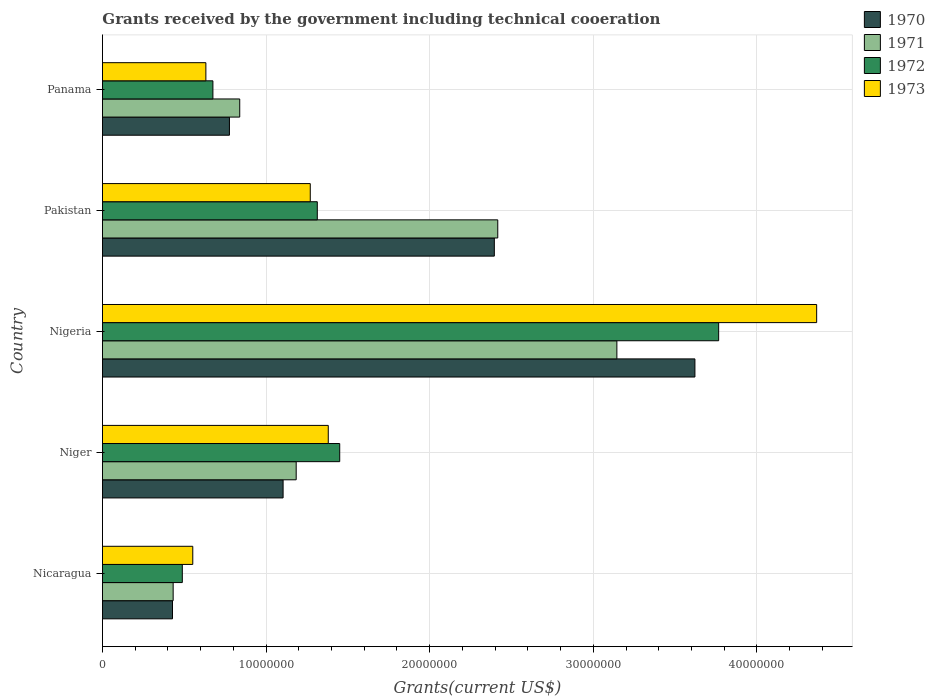Are the number of bars on each tick of the Y-axis equal?
Your answer should be very brief. Yes. How many bars are there on the 5th tick from the top?
Make the answer very short. 4. What is the total grants received by the government in 1970 in Nicaragua?
Provide a succinct answer. 4.28e+06. Across all countries, what is the maximum total grants received by the government in 1970?
Make the answer very short. 3.62e+07. Across all countries, what is the minimum total grants received by the government in 1970?
Make the answer very short. 4.28e+06. In which country was the total grants received by the government in 1970 maximum?
Ensure brevity in your answer.  Nigeria. In which country was the total grants received by the government in 1972 minimum?
Provide a succinct answer. Nicaragua. What is the total total grants received by the government in 1973 in the graph?
Your answer should be very brief. 8.20e+07. What is the difference between the total grants received by the government in 1971 in Nigeria and that in Pakistan?
Offer a terse response. 7.28e+06. What is the difference between the total grants received by the government in 1972 in Niger and the total grants received by the government in 1970 in Panama?
Provide a short and direct response. 6.74e+06. What is the average total grants received by the government in 1972 per country?
Your answer should be compact. 1.54e+07. What is the difference between the total grants received by the government in 1973 and total grants received by the government in 1971 in Nigeria?
Provide a short and direct response. 1.22e+07. In how many countries, is the total grants received by the government in 1971 greater than 30000000 US$?
Ensure brevity in your answer.  1. What is the ratio of the total grants received by the government in 1970 in Nigeria to that in Pakistan?
Offer a very short reply. 1.51. What is the difference between the highest and the second highest total grants received by the government in 1973?
Give a very brief answer. 2.98e+07. What is the difference between the highest and the lowest total grants received by the government in 1971?
Offer a terse response. 2.71e+07. Is the sum of the total grants received by the government in 1970 in Nigeria and Pakistan greater than the maximum total grants received by the government in 1973 across all countries?
Offer a terse response. Yes. Is it the case that in every country, the sum of the total grants received by the government in 1971 and total grants received by the government in 1973 is greater than the sum of total grants received by the government in 1972 and total grants received by the government in 1970?
Make the answer very short. No. What does the 3rd bar from the top in Niger represents?
Offer a terse response. 1971. What does the 1st bar from the bottom in Niger represents?
Make the answer very short. 1970. Is it the case that in every country, the sum of the total grants received by the government in 1971 and total grants received by the government in 1973 is greater than the total grants received by the government in 1970?
Keep it short and to the point. Yes. How many countries are there in the graph?
Your response must be concise. 5. What is the difference between two consecutive major ticks on the X-axis?
Offer a terse response. 1.00e+07. Are the values on the major ticks of X-axis written in scientific E-notation?
Offer a terse response. No. Does the graph contain any zero values?
Offer a very short reply. No. Does the graph contain grids?
Ensure brevity in your answer.  Yes. Where does the legend appear in the graph?
Your response must be concise. Top right. How many legend labels are there?
Your answer should be compact. 4. How are the legend labels stacked?
Ensure brevity in your answer.  Vertical. What is the title of the graph?
Offer a very short reply. Grants received by the government including technical cooeration. Does "1991" appear as one of the legend labels in the graph?
Your answer should be compact. No. What is the label or title of the X-axis?
Keep it short and to the point. Grants(current US$). What is the label or title of the Y-axis?
Offer a terse response. Country. What is the Grants(current US$) of 1970 in Nicaragua?
Your response must be concise. 4.28e+06. What is the Grants(current US$) in 1971 in Nicaragua?
Your answer should be compact. 4.32e+06. What is the Grants(current US$) in 1972 in Nicaragua?
Provide a succinct answer. 4.88e+06. What is the Grants(current US$) in 1973 in Nicaragua?
Offer a terse response. 5.52e+06. What is the Grants(current US$) of 1970 in Niger?
Make the answer very short. 1.10e+07. What is the Grants(current US$) of 1971 in Niger?
Your response must be concise. 1.18e+07. What is the Grants(current US$) in 1972 in Niger?
Provide a short and direct response. 1.45e+07. What is the Grants(current US$) of 1973 in Niger?
Provide a succinct answer. 1.38e+07. What is the Grants(current US$) in 1970 in Nigeria?
Your answer should be very brief. 3.62e+07. What is the Grants(current US$) of 1971 in Nigeria?
Provide a short and direct response. 3.14e+07. What is the Grants(current US$) of 1972 in Nigeria?
Your answer should be very brief. 3.77e+07. What is the Grants(current US$) in 1973 in Nigeria?
Offer a very short reply. 4.36e+07. What is the Grants(current US$) in 1970 in Pakistan?
Offer a terse response. 2.40e+07. What is the Grants(current US$) in 1971 in Pakistan?
Keep it short and to the point. 2.42e+07. What is the Grants(current US$) of 1972 in Pakistan?
Make the answer very short. 1.31e+07. What is the Grants(current US$) of 1973 in Pakistan?
Ensure brevity in your answer.  1.27e+07. What is the Grants(current US$) in 1970 in Panama?
Provide a succinct answer. 7.76e+06. What is the Grants(current US$) in 1971 in Panama?
Give a very brief answer. 8.39e+06. What is the Grants(current US$) of 1972 in Panama?
Keep it short and to the point. 6.75e+06. What is the Grants(current US$) in 1973 in Panama?
Offer a terse response. 6.32e+06. Across all countries, what is the maximum Grants(current US$) of 1970?
Provide a short and direct response. 3.62e+07. Across all countries, what is the maximum Grants(current US$) in 1971?
Keep it short and to the point. 3.14e+07. Across all countries, what is the maximum Grants(current US$) of 1972?
Your answer should be compact. 3.77e+07. Across all countries, what is the maximum Grants(current US$) in 1973?
Keep it short and to the point. 4.36e+07. Across all countries, what is the minimum Grants(current US$) in 1970?
Your answer should be compact. 4.28e+06. Across all countries, what is the minimum Grants(current US$) in 1971?
Give a very brief answer. 4.32e+06. Across all countries, what is the minimum Grants(current US$) of 1972?
Give a very brief answer. 4.88e+06. Across all countries, what is the minimum Grants(current US$) in 1973?
Your answer should be very brief. 5.52e+06. What is the total Grants(current US$) in 1970 in the graph?
Your answer should be compact. 8.32e+07. What is the total Grants(current US$) of 1971 in the graph?
Your response must be concise. 8.02e+07. What is the total Grants(current US$) in 1972 in the graph?
Ensure brevity in your answer.  7.69e+07. What is the total Grants(current US$) of 1973 in the graph?
Your answer should be very brief. 8.20e+07. What is the difference between the Grants(current US$) of 1970 in Nicaragua and that in Niger?
Offer a very short reply. -6.76e+06. What is the difference between the Grants(current US$) in 1971 in Nicaragua and that in Niger?
Provide a short and direct response. -7.52e+06. What is the difference between the Grants(current US$) in 1972 in Nicaragua and that in Niger?
Provide a succinct answer. -9.62e+06. What is the difference between the Grants(current US$) in 1973 in Nicaragua and that in Niger?
Keep it short and to the point. -8.28e+06. What is the difference between the Grants(current US$) in 1970 in Nicaragua and that in Nigeria?
Your response must be concise. -3.19e+07. What is the difference between the Grants(current US$) of 1971 in Nicaragua and that in Nigeria?
Your answer should be very brief. -2.71e+07. What is the difference between the Grants(current US$) in 1972 in Nicaragua and that in Nigeria?
Offer a terse response. -3.28e+07. What is the difference between the Grants(current US$) of 1973 in Nicaragua and that in Nigeria?
Provide a succinct answer. -3.81e+07. What is the difference between the Grants(current US$) in 1970 in Nicaragua and that in Pakistan?
Your answer should be very brief. -1.97e+07. What is the difference between the Grants(current US$) in 1971 in Nicaragua and that in Pakistan?
Your answer should be very brief. -1.98e+07. What is the difference between the Grants(current US$) of 1972 in Nicaragua and that in Pakistan?
Offer a very short reply. -8.25e+06. What is the difference between the Grants(current US$) in 1973 in Nicaragua and that in Pakistan?
Your answer should be compact. -7.18e+06. What is the difference between the Grants(current US$) in 1970 in Nicaragua and that in Panama?
Ensure brevity in your answer.  -3.48e+06. What is the difference between the Grants(current US$) in 1971 in Nicaragua and that in Panama?
Ensure brevity in your answer.  -4.07e+06. What is the difference between the Grants(current US$) of 1972 in Nicaragua and that in Panama?
Provide a succinct answer. -1.87e+06. What is the difference between the Grants(current US$) of 1973 in Nicaragua and that in Panama?
Your answer should be compact. -8.00e+05. What is the difference between the Grants(current US$) in 1970 in Niger and that in Nigeria?
Offer a very short reply. -2.52e+07. What is the difference between the Grants(current US$) of 1971 in Niger and that in Nigeria?
Offer a very short reply. -1.96e+07. What is the difference between the Grants(current US$) of 1972 in Niger and that in Nigeria?
Provide a succinct answer. -2.32e+07. What is the difference between the Grants(current US$) in 1973 in Niger and that in Nigeria?
Give a very brief answer. -2.98e+07. What is the difference between the Grants(current US$) of 1970 in Niger and that in Pakistan?
Your response must be concise. -1.29e+07. What is the difference between the Grants(current US$) in 1971 in Niger and that in Pakistan?
Ensure brevity in your answer.  -1.23e+07. What is the difference between the Grants(current US$) of 1972 in Niger and that in Pakistan?
Your answer should be compact. 1.37e+06. What is the difference between the Grants(current US$) in 1973 in Niger and that in Pakistan?
Your answer should be compact. 1.10e+06. What is the difference between the Grants(current US$) in 1970 in Niger and that in Panama?
Your answer should be very brief. 3.28e+06. What is the difference between the Grants(current US$) of 1971 in Niger and that in Panama?
Your answer should be compact. 3.45e+06. What is the difference between the Grants(current US$) in 1972 in Niger and that in Panama?
Offer a very short reply. 7.75e+06. What is the difference between the Grants(current US$) of 1973 in Niger and that in Panama?
Give a very brief answer. 7.48e+06. What is the difference between the Grants(current US$) in 1970 in Nigeria and that in Pakistan?
Provide a short and direct response. 1.23e+07. What is the difference between the Grants(current US$) in 1971 in Nigeria and that in Pakistan?
Provide a short and direct response. 7.28e+06. What is the difference between the Grants(current US$) in 1972 in Nigeria and that in Pakistan?
Ensure brevity in your answer.  2.45e+07. What is the difference between the Grants(current US$) in 1973 in Nigeria and that in Pakistan?
Your response must be concise. 3.10e+07. What is the difference between the Grants(current US$) of 1970 in Nigeria and that in Panama?
Your response must be concise. 2.84e+07. What is the difference between the Grants(current US$) in 1971 in Nigeria and that in Panama?
Offer a terse response. 2.30e+07. What is the difference between the Grants(current US$) in 1972 in Nigeria and that in Panama?
Keep it short and to the point. 3.09e+07. What is the difference between the Grants(current US$) of 1973 in Nigeria and that in Panama?
Offer a terse response. 3.73e+07. What is the difference between the Grants(current US$) in 1970 in Pakistan and that in Panama?
Your answer should be very brief. 1.62e+07. What is the difference between the Grants(current US$) of 1971 in Pakistan and that in Panama?
Offer a terse response. 1.58e+07. What is the difference between the Grants(current US$) in 1972 in Pakistan and that in Panama?
Give a very brief answer. 6.38e+06. What is the difference between the Grants(current US$) of 1973 in Pakistan and that in Panama?
Offer a terse response. 6.38e+06. What is the difference between the Grants(current US$) in 1970 in Nicaragua and the Grants(current US$) in 1971 in Niger?
Offer a terse response. -7.56e+06. What is the difference between the Grants(current US$) of 1970 in Nicaragua and the Grants(current US$) of 1972 in Niger?
Give a very brief answer. -1.02e+07. What is the difference between the Grants(current US$) of 1970 in Nicaragua and the Grants(current US$) of 1973 in Niger?
Offer a very short reply. -9.52e+06. What is the difference between the Grants(current US$) in 1971 in Nicaragua and the Grants(current US$) in 1972 in Niger?
Give a very brief answer. -1.02e+07. What is the difference between the Grants(current US$) of 1971 in Nicaragua and the Grants(current US$) of 1973 in Niger?
Offer a terse response. -9.48e+06. What is the difference between the Grants(current US$) of 1972 in Nicaragua and the Grants(current US$) of 1973 in Niger?
Offer a very short reply. -8.92e+06. What is the difference between the Grants(current US$) in 1970 in Nicaragua and the Grants(current US$) in 1971 in Nigeria?
Keep it short and to the point. -2.72e+07. What is the difference between the Grants(current US$) in 1970 in Nicaragua and the Grants(current US$) in 1972 in Nigeria?
Provide a succinct answer. -3.34e+07. What is the difference between the Grants(current US$) of 1970 in Nicaragua and the Grants(current US$) of 1973 in Nigeria?
Offer a terse response. -3.94e+07. What is the difference between the Grants(current US$) in 1971 in Nicaragua and the Grants(current US$) in 1972 in Nigeria?
Give a very brief answer. -3.33e+07. What is the difference between the Grants(current US$) in 1971 in Nicaragua and the Grants(current US$) in 1973 in Nigeria?
Provide a short and direct response. -3.93e+07. What is the difference between the Grants(current US$) in 1972 in Nicaragua and the Grants(current US$) in 1973 in Nigeria?
Make the answer very short. -3.88e+07. What is the difference between the Grants(current US$) of 1970 in Nicaragua and the Grants(current US$) of 1971 in Pakistan?
Provide a short and direct response. -1.99e+07. What is the difference between the Grants(current US$) of 1970 in Nicaragua and the Grants(current US$) of 1972 in Pakistan?
Offer a terse response. -8.85e+06. What is the difference between the Grants(current US$) in 1970 in Nicaragua and the Grants(current US$) in 1973 in Pakistan?
Keep it short and to the point. -8.42e+06. What is the difference between the Grants(current US$) of 1971 in Nicaragua and the Grants(current US$) of 1972 in Pakistan?
Your answer should be very brief. -8.81e+06. What is the difference between the Grants(current US$) of 1971 in Nicaragua and the Grants(current US$) of 1973 in Pakistan?
Keep it short and to the point. -8.38e+06. What is the difference between the Grants(current US$) of 1972 in Nicaragua and the Grants(current US$) of 1973 in Pakistan?
Give a very brief answer. -7.82e+06. What is the difference between the Grants(current US$) in 1970 in Nicaragua and the Grants(current US$) in 1971 in Panama?
Offer a terse response. -4.11e+06. What is the difference between the Grants(current US$) of 1970 in Nicaragua and the Grants(current US$) of 1972 in Panama?
Make the answer very short. -2.47e+06. What is the difference between the Grants(current US$) in 1970 in Nicaragua and the Grants(current US$) in 1973 in Panama?
Your answer should be compact. -2.04e+06. What is the difference between the Grants(current US$) of 1971 in Nicaragua and the Grants(current US$) of 1972 in Panama?
Keep it short and to the point. -2.43e+06. What is the difference between the Grants(current US$) of 1972 in Nicaragua and the Grants(current US$) of 1973 in Panama?
Your answer should be very brief. -1.44e+06. What is the difference between the Grants(current US$) of 1970 in Niger and the Grants(current US$) of 1971 in Nigeria?
Offer a terse response. -2.04e+07. What is the difference between the Grants(current US$) in 1970 in Niger and the Grants(current US$) in 1972 in Nigeria?
Provide a succinct answer. -2.66e+07. What is the difference between the Grants(current US$) in 1970 in Niger and the Grants(current US$) in 1973 in Nigeria?
Provide a short and direct response. -3.26e+07. What is the difference between the Grants(current US$) of 1971 in Niger and the Grants(current US$) of 1972 in Nigeria?
Ensure brevity in your answer.  -2.58e+07. What is the difference between the Grants(current US$) in 1971 in Niger and the Grants(current US$) in 1973 in Nigeria?
Ensure brevity in your answer.  -3.18e+07. What is the difference between the Grants(current US$) in 1972 in Niger and the Grants(current US$) in 1973 in Nigeria?
Your answer should be compact. -2.92e+07. What is the difference between the Grants(current US$) of 1970 in Niger and the Grants(current US$) of 1971 in Pakistan?
Make the answer very short. -1.31e+07. What is the difference between the Grants(current US$) of 1970 in Niger and the Grants(current US$) of 1972 in Pakistan?
Your response must be concise. -2.09e+06. What is the difference between the Grants(current US$) in 1970 in Niger and the Grants(current US$) in 1973 in Pakistan?
Ensure brevity in your answer.  -1.66e+06. What is the difference between the Grants(current US$) of 1971 in Niger and the Grants(current US$) of 1972 in Pakistan?
Ensure brevity in your answer.  -1.29e+06. What is the difference between the Grants(current US$) of 1971 in Niger and the Grants(current US$) of 1973 in Pakistan?
Offer a very short reply. -8.60e+05. What is the difference between the Grants(current US$) in 1972 in Niger and the Grants(current US$) in 1973 in Pakistan?
Provide a short and direct response. 1.80e+06. What is the difference between the Grants(current US$) in 1970 in Niger and the Grants(current US$) in 1971 in Panama?
Keep it short and to the point. 2.65e+06. What is the difference between the Grants(current US$) of 1970 in Niger and the Grants(current US$) of 1972 in Panama?
Provide a short and direct response. 4.29e+06. What is the difference between the Grants(current US$) of 1970 in Niger and the Grants(current US$) of 1973 in Panama?
Ensure brevity in your answer.  4.72e+06. What is the difference between the Grants(current US$) of 1971 in Niger and the Grants(current US$) of 1972 in Panama?
Your response must be concise. 5.09e+06. What is the difference between the Grants(current US$) of 1971 in Niger and the Grants(current US$) of 1973 in Panama?
Give a very brief answer. 5.52e+06. What is the difference between the Grants(current US$) in 1972 in Niger and the Grants(current US$) in 1973 in Panama?
Your answer should be compact. 8.18e+06. What is the difference between the Grants(current US$) in 1970 in Nigeria and the Grants(current US$) in 1971 in Pakistan?
Your answer should be compact. 1.20e+07. What is the difference between the Grants(current US$) of 1970 in Nigeria and the Grants(current US$) of 1972 in Pakistan?
Your answer should be very brief. 2.31e+07. What is the difference between the Grants(current US$) in 1970 in Nigeria and the Grants(current US$) in 1973 in Pakistan?
Your answer should be compact. 2.35e+07. What is the difference between the Grants(current US$) of 1971 in Nigeria and the Grants(current US$) of 1972 in Pakistan?
Your answer should be very brief. 1.83e+07. What is the difference between the Grants(current US$) in 1971 in Nigeria and the Grants(current US$) in 1973 in Pakistan?
Ensure brevity in your answer.  1.87e+07. What is the difference between the Grants(current US$) of 1972 in Nigeria and the Grants(current US$) of 1973 in Pakistan?
Make the answer very short. 2.50e+07. What is the difference between the Grants(current US$) in 1970 in Nigeria and the Grants(current US$) in 1971 in Panama?
Give a very brief answer. 2.78e+07. What is the difference between the Grants(current US$) of 1970 in Nigeria and the Grants(current US$) of 1972 in Panama?
Offer a very short reply. 2.95e+07. What is the difference between the Grants(current US$) of 1970 in Nigeria and the Grants(current US$) of 1973 in Panama?
Ensure brevity in your answer.  2.99e+07. What is the difference between the Grants(current US$) in 1971 in Nigeria and the Grants(current US$) in 1972 in Panama?
Offer a terse response. 2.47e+07. What is the difference between the Grants(current US$) of 1971 in Nigeria and the Grants(current US$) of 1973 in Panama?
Provide a succinct answer. 2.51e+07. What is the difference between the Grants(current US$) in 1972 in Nigeria and the Grants(current US$) in 1973 in Panama?
Your answer should be compact. 3.13e+07. What is the difference between the Grants(current US$) in 1970 in Pakistan and the Grants(current US$) in 1971 in Panama?
Provide a succinct answer. 1.56e+07. What is the difference between the Grants(current US$) of 1970 in Pakistan and the Grants(current US$) of 1972 in Panama?
Provide a succinct answer. 1.72e+07. What is the difference between the Grants(current US$) in 1970 in Pakistan and the Grants(current US$) in 1973 in Panama?
Give a very brief answer. 1.76e+07. What is the difference between the Grants(current US$) in 1971 in Pakistan and the Grants(current US$) in 1972 in Panama?
Offer a very short reply. 1.74e+07. What is the difference between the Grants(current US$) of 1971 in Pakistan and the Grants(current US$) of 1973 in Panama?
Give a very brief answer. 1.78e+07. What is the difference between the Grants(current US$) of 1972 in Pakistan and the Grants(current US$) of 1973 in Panama?
Ensure brevity in your answer.  6.81e+06. What is the average Grants(current US$) in 1970 per country?
Make the answer very short. 1.66e+07. What is the average Grants(current US$) in 1971 per country?
Keep it short and to the point. 1.60e+07. What is the average Grants(current US$) in 1972 per country?
Your answer should be very brief. 1.54e+07. What is the average Grants(current US$) in 1973 per country?
Make the answer very short. 1.64e+07. What is the difference between the Grants(current US$) in 1970 and Grants(current US$) in 1971 in Nicaragua?
Give a very brief answer. -4.00e+04. What is the difference between the Grants(current US$) of 1970 and Grants(current US$) of 1972 in Nicaragua?
Provide a succinct answer. -6.00e+05. What is the difference between the Grants(current US$) of 1970 and Grants(current US$) of 1973 in Nicaragua?
Your answer should be compact. -1.24e+06. What is the difference between the Grants(current US$) in 1971 and Grants(current US$) in 1972 in Nicaragua?
Offer a very short reply. -5.60e+05. What is the difference between the Grants(current US$) in 1971 and Grants(current US$) in 1973 in Nicaragua?
Offer a very short reply. -1.20e+06. What is the difference between the Grants(current US$) in 1972 and Grants(current US$) in 1973 in Nicaragua?
Keep it short and to the point. -6.40e+05. What is the difference between the Grants(current US$) in 1970 and Grants(current US$) in 1971 in Niger?
Give a very brief answer. -8.00e+05. What is the difference between the Grants(current US$) in 1970 and Grants(current US$) in 1972 in Niger?
Your answer should be very brief. -3.46e+06. What is the difference between the Grants(current US$) of 1970 and Grants(current US$) of 1973 in Niger?
Keep it short and to the point. -2.76e+06. What is the difference between the Grants(current US$) in 1971 and Grants(current US$) in 1972 in Niger?
Your response must be concise. -2.66e+06. What is the difference between the Grants(current US$) of 1971 and Grants(current US$) of 1973 in Niger?
Offer a terse response. -1.96e+06. What is the difference between the Grants(current US$) of 1972 and Grants(current US$) of 1973 in Niger?
Give a very brief answer. 7.00e+05. What is the difference between the Grants(current US$) in 1970 and Grants(current US$) in 1971 in Nigeria?
Offer a very short reply. 4.77e+06. What is the difference between the Grants(current US$) in 1970 and Grants(current US$) in 1972 in Nigeria?
Give a very brief answer. -1.45e+06. What is the difference between the Grants(current US$) of 1970 and Grants(current US$) of 1973 in Nigeria?
Give a very brief answer. -7.44e+06. What is the difference between the Grants(current US$) of 1971 and Grants(current US$) of 1972 in Nigeria?
Your answer should be very brief. -6.22e+06. What is the difference between the Grants(current US$) of 1971 and Grants(current US$) of 1973 in Nigeria?
Ensure brevity in your answer.  -1.22e+07. What is the difference between the Grants(current US$) in 1972 and Grants(current US$) in 1973 in Nigeria?
Your answer should be very brief. -5.99e+06. What is the difference between the Grants(current US$) in 1970 and Grants(current US$) in 1972 in Pakistan?
Offer a terse response. 1.08e+07. What is the difference between the Grants(current US$) in 1970 and Grants(current US$) in 1973 in Pakistan?
Offer a very short reply. 1.12e+07. What is the difference between the Grants(current US$) of 1971 and Grants(current US$) of 1972 in Pakistan?
Provide a short and direct response. 1.10e+07. What is the difference between the Grants(current US$) in 1971 and Grants(current US$) in 1973 in Pakistan?
Provide a succinct answer. 1.15e+07. What is the difference between the Grants(current US$) in 1972 and Grants(current US$) in 1973 in Pakistan?
Give a very brief answer. 4.30e+05. What is the difference between the Grants(current US$) of 1970 and Grants(current US$) of 1971 in Panama?
Your answer should be very brief. -6.30e+05. What is the difference between the Grants(current US$) of 1970 and Grants(current US$) of 1972 in Panama?
Keep it short and to the point. 1.01e+06. What is the difference between the Grants(current US$) of 1970 and Grants(current US$) of 1973 in Panama?
Provide a succinct answer. 1.44e+06. What is the difference between the Grants(current US$) in 1971 and Grants(current US$) in 1972 in Panama?
Give a very brief answer. 1.64e+06. What is the difference between the Grants(current US$) of 1971 and Grants(current US$) of 1973 in Panama?
Your answer should be very brief. 2.07e+06. What is the difference between the Grants(current US$) of 1972 and Grants(current US$) of 1973 in Panama?
Ensure brevity in your answer.  4.30e+05. What is the ratio of the Grants(current US$) of 1970 in Nicaragua to that in Niger?
Provide a succinct answer. 0.39. What is the ratio of the Grants(current US$) in 1971 in Nicaragua to that in Niger?
Ensure brevity in your answer.  0.36. What is the ratio of the Grants(current US$) of 1972 in Nicaragua to that in Niger?
Provide a succinct answer. 0.34. What is the ratio of the Grants(current US$) of 1973 in Nicaragua to that in Niger?
Provide a succinct answer. 0.4. What is the ratio of the Grants(current US$) in 1970 in Nicaragua to that in Nigeria?
Provide a succinct answer. 0.12. What is the ratio of the Grants(current US$) in 1971 in Nicaragua to that in Nigeria?
Offer a very short reply. 0.14. What is the ratio of the Grants(current US$) of 1972 in Nicaragua to that in Nigeria?
Provide a short and direct response. 0.13. What is the ratio of the Grants(current US$) of 1973 in Nicaragua to that in Nigeria?
Ensure brevity in your answer.  0.13. What is the ratio of the Grants(current US$) in 1970 in Nicaragua to that in Pakistan?
Offer a very short reply. 0.18. What is the ratio of the Grants(current US$) of 1971 in Nicaragua to that in Pakistan?
Keep it short and to the point. 0.18. What is the ratio of the Grants(current US$) in 1972 in Nicaragua to that in Pakistan?
Offer a terse response. 0.37. What is the ratio of the Grants(current US$) in 1973 in Nicaragua to that in Pakistan?
Provide a succinct answer. 0.43. What is the ratio of the Grants(current US$) in 1970 in Nicaragua to that in Panama?
Your answer should be compact. 0.55. What is the ratio of the Grants(current US$) in 1971 in Nicaragua to that in Panama?
Make the answer very short. 0.51. What is the ratio of the Grants(current US$) in 1972 in Nicaragua to that in Panama?
Provide a succinct answer. 0.72. What is the ratio of the Grants(current US$) of 1973 in Nicaragua to that in Panama?
Provide a short and direct response. 0.87. What is the ratio of the Grants(current US$) of 1970 in Niger to that in Nigeria?
Make the answer very short. 0.3. What is the ratio of the Grants(current US$) in 1971 in Niger to that in Nigeria?
Make the answer very short. 0.38. What is the ratio of the Grants(current US$) of 1972 in Niger to that in Nigeria?
Ensure brevity in your answer.  0.39. What is the ratio of the Grants(current US$) of 1973 in Niger to that in Nigeria?
Ensure brevity in your answer.  0.32. What is the ratio of the Grants(current US$) of 1970 in Niger to that in Pakistan?
Keep it short and to the point. 0.46. What is the ratio of the Grants(current US$) of 1971 in Niger to that in Pakistan?
Offer a very short reply. 0.49. What is the ratio of the Grants(current US$) of 1972 in Niger to that in Pakistan?
Your response must be concise. 1.1. What is the ratio of the Grants(current US$) of 1973 in Niger to that in Pakistan?
Provide a succinct answer. 1.09. What is the ratio of the Grants(current US$) in 1970 in Niger to that in Panama?
Your response must be concise. 1.42. What is the ratio of the Grants(current US$) in 1971 in Niger to that in Panama?
Give a very brief answer. 1.41. What is the ratio of the Grants(current US$) in 1972 in Niger to that in Panama?
Your answer should be compact. 2.15. What is the ratio of the Grants(current US$) in 1973 in Niger to that in Panama?
Keep it short and to the point. 2.18. What is the ratio of the Grants(current US$) in 1970 in Nigeria to that in Pakistan?
Your answer should be very brief. 1.51. What is the ratio of the Grants(current US$) of 1971 in Nigeria to that in Pakistan?
Give a very brief answer. 1.3. What is the ratio of the Grants(current US$) of 1972 in Nigeria to that in Pakistan?
Ensure brevity in your answer.  2.87. What is the ratio of the Grants(current US$) in 1973 in Nigeria to that in Pakistan?
Keep it short and to the point. 3.44. What is the ratio of the Grants(current US$) in 1970 in Nigeria to that in Panama?
Your response must be concise. 4.67. What is the ratio of the Grants(current US$) in 1971 in Nigeria to that in Panama?
Ensure brevity in your answer.  3.75. What is the ratio of the Grants(current US$) of 1972 in Nigeria to that in Panama?
Make the answer very short. 5.58. What is the ratio of the Grants(current US$) in 1973 in Nigeria to that in Panama?
Your response must be concise. 6.91. What is the ratio of the Grants(current US$) of 1970 in Pakistan to that in Panama?
Provide a short and direct response. 3.09. What is the ratio of the Grants(current US$) of 1971 in Pakistan to that in Panama?
Your answer should be very brief. 2.88. What is the ratio of the Grants(current US$) of 1972 in Pakistan to that in Panama?
Make the answer very short. 1.95. What is the ratio of the Grants(current US$) in 1973 in Pakistan to that in Panama?
Ensure brevity in your answer.  2.01. What is the difference between the highest and the second highest Grants(current US$) in 1970?
Ensure brevity in your answer.  1.23e+07. What is the difference between the highest and the second highest Grants(current US$) of 1971?
Your response must be concise. 7.28e+06. What is the difference between the highest and the second highest Grants(current US$) of 1972?
Give a very brief answer. 2.32e+07. What is the difference between the highest and the second highest Grants(current US$) of 1973?
Your answer should be compact. 2.98e+07. What is the difference between the highest and the lowest Grants(current US$) of 1970?
Make the answer very short. 3.19e+07. What is the difference between the highest and the lowest Grants(current US$) in 1971?
Provide a succinct answer. 2.71e+07. What is the difference between the highest and the lowest Grants(current US$) in 1972?
Provide a succinct answer. 3.28e+07. What is the difference between the highest and the lowest Grants(current US$) of 1973?
Give a very brief answer. 3.81e+07. 